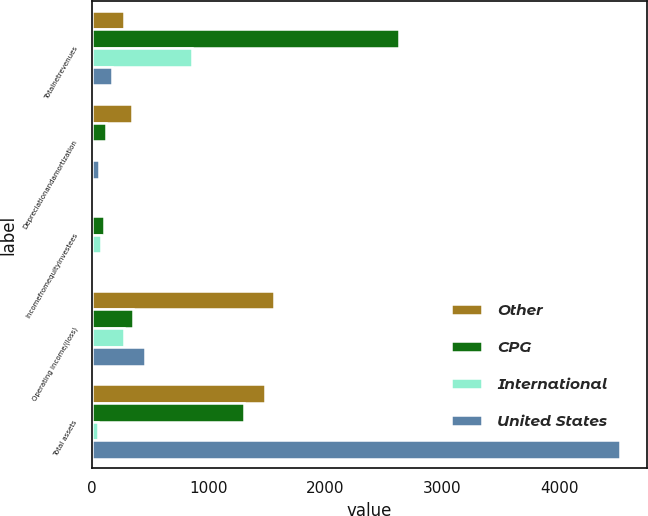<chart> <loc_0><loc_0><loc_500><loc_500><stacked_bar_chart><ecel><fcel>Totalnetrevenues<fcel>Depreciationandamortization<fcel>Incomefromequityinvestees<fcel>Operating income/(loss)<fcel>Total assets<nl><fcel>Other<fcel>273<fcel>343.8<fcel>0<fcel>1562.6<fcel>1479.4<nl><fcel>CPG<fcel>2626.1<fcel>118.5<fcel>100.5<fcel>349.7<fcel>1300.7<nl><fcel>International<fcel>860.5<fcel>2.4<fcel>75.6<fcel>273<fcel>54.7<nl><fcel>United States<fcel>175.8<fcel>58.6<fcel>2.4<fcel>456.8<fcel>4525.6<nl></chart> 